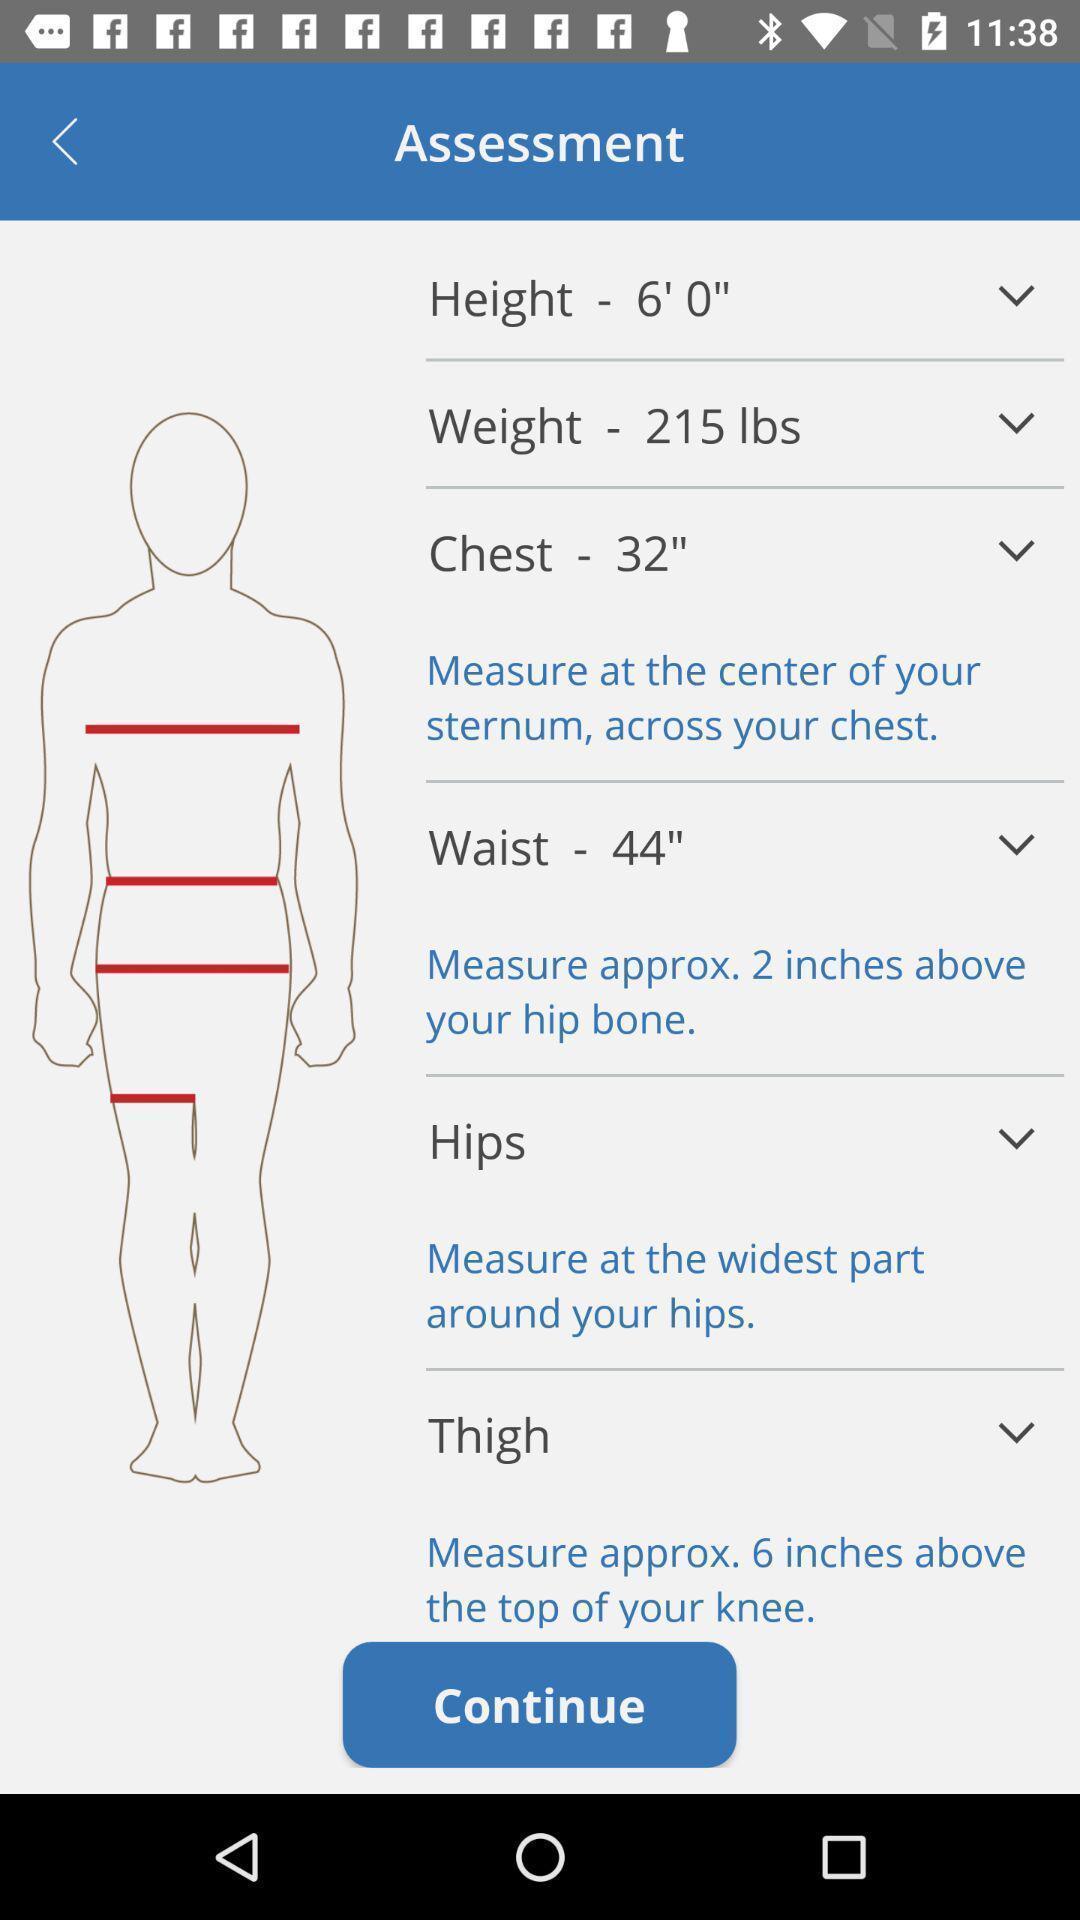Explain what's happening in this screen capture. Screen displaying the body measurements. 